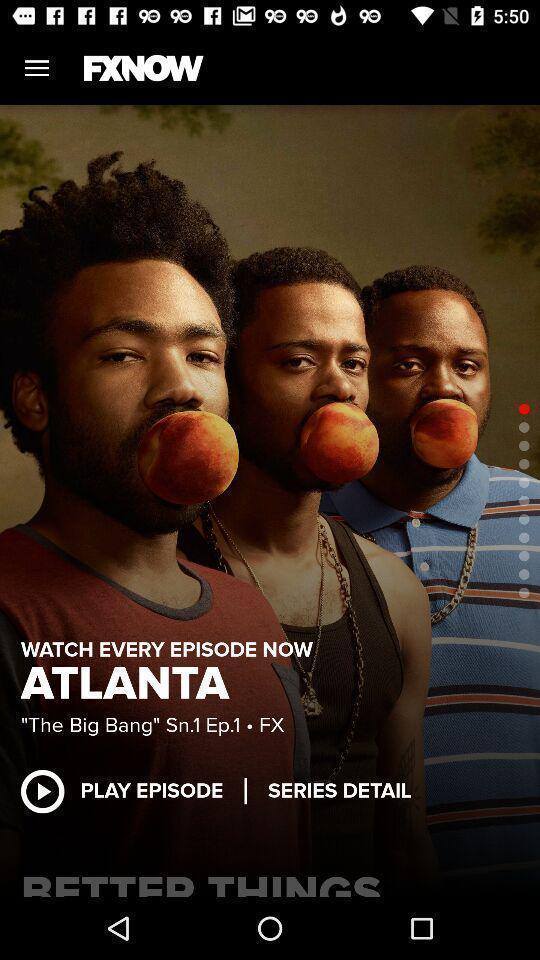Describe the key features of this screenshot. Screen showing play episode. 